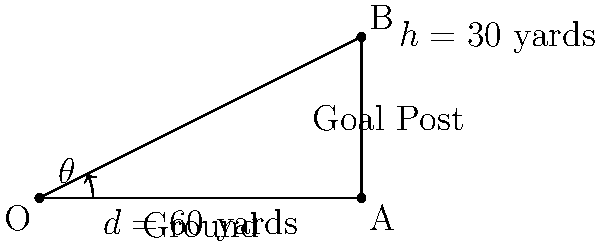As a football coach, you're preparing your kicker for a crucial field goal. The ball will be placed 60 yards away from the goal post, which is 30 yards high. What is the optimal angle $\theta$ (in degrees, rounded to the nearest whole number) at which the kicker should kick the ball to clear the crossbar, assuming no air resistance and a straight trajectory? To solve this problem, we'll use trigonometry:

1) The field goal scenario forms a right triangle, where:
   - The adjacent side (d) is 60 yards (distance to goal post)
   - The opposite side (h) is 30 yards (height of goal post)
   - The angle $\theta$ is what we need to find

2) We can use the tangent function to find the angle:

   $$\tan(\theta) = \frac{\text{opposite}}{\text{adjacent}} = \frac{h}{d} = \frac{30}{60} = \frac{1}{2}$$

3) To find $\theta$, we need to use the inverse tangent (arctan or $\tan^{-1}$):

   $$\theta = \tan^{-1}(\frac{1}{2})$$

4) Using a calculator or trigonometric tables:

   $$\theta \approx 26.57°$$

5) Rounding to the nearest whole number:

   $$\theta \approx 27°$$

This angle would allow the ball to just clear the crossbar. However, in a real game scenario, you might want to add a small safety margin to account for factors like air resistance and potential blocking by the opposing team.
Answer: 27° 